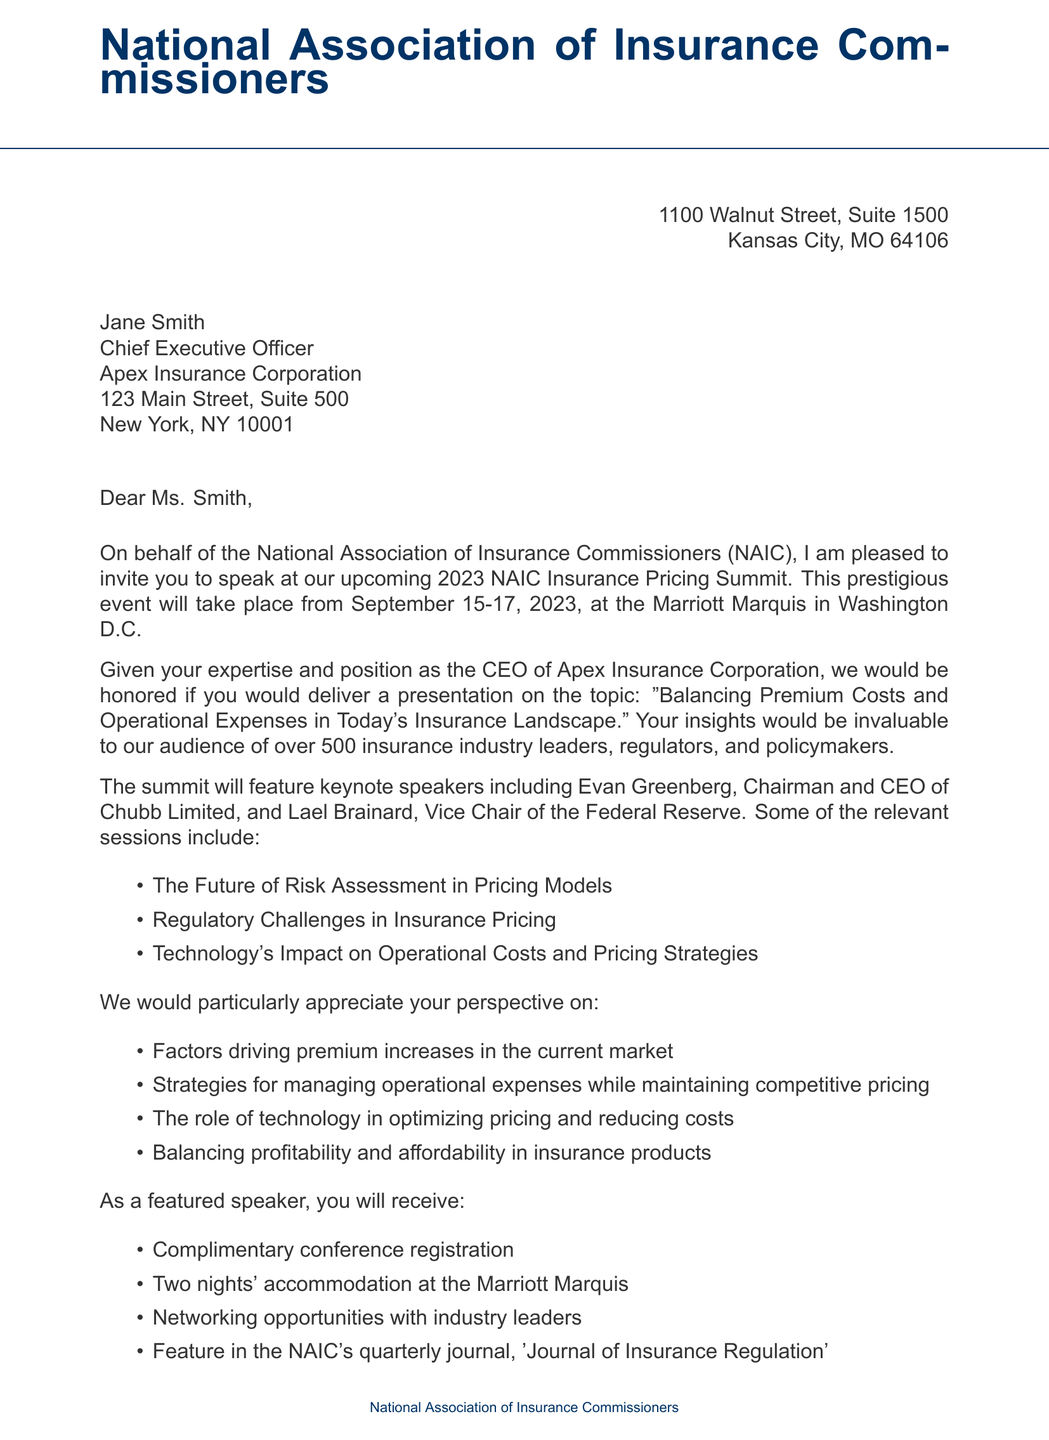What is the name of the event? The event name is mentioned in the invitation section of the document as the "2023 NAIC Insurance Pricing Summit."
Answer: 2023 NAIC Insurance Pricing Summit When will the event take place? The document specifies the event dates as September 15-17, 2023, in the invitation section.
Answer: September 15-17, 2023 Where is the summit located? The location of the summit is provided in the invitation section as the Marriott Marquis, Washington D.C.
Answer: Marriott Marquis, Washington D.C Who is one of the keynote speakers? The document lists keynote speakers, one of which is Evan Greenberg, Chairman and CEO of Chubb Limited.
Answer: Evan Greenberg What percentage of premiums was the operating expense ratio in Q4 2022? This information is included in the relevant statistics section of the document, indicating the industry operating expense ratio was 27.3% of premiums.
Answer: 27.3% What is the deadline for confirming participation? The confirmation deadline is stated in the document, and it is July 15, 2023.
Answer: July 15, 2023 What incentive is offered for participating as a speaker? It mentions complimentary conference registration as one of the benefits for speakers.
Answer: Complimentary conference registration Which topic relates to managing operational costs? The document lists presentation topics, including "Strategies for managing operational expenses while maintaining competitive pricing."
Answer: Strategies for managing operational expenses while maintaining competitive pricing Who should be contacted for further information? The contact information section names Michael Johnson as the person to contact for further information.
Answer: Michael Johnson 